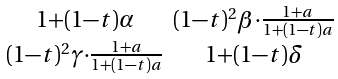<formula> <loc_0><loc_0><loc_500><loc_500>\begin{smallmatrix} 1 + ( 1 - t ) \alpha & ( 1 - t ) ^ { 2 } \beta \cdot \frac { 1 + a } { 1 + ( 1 - t ) a } \\ ( 1 - t ) ^ { 2 } \gamma \cdot \frac { 1 + a } { 1 + ( 1 - t ) a } & 1 + ( 1 - t ) \delta \end{smallmatrix}</formula> 